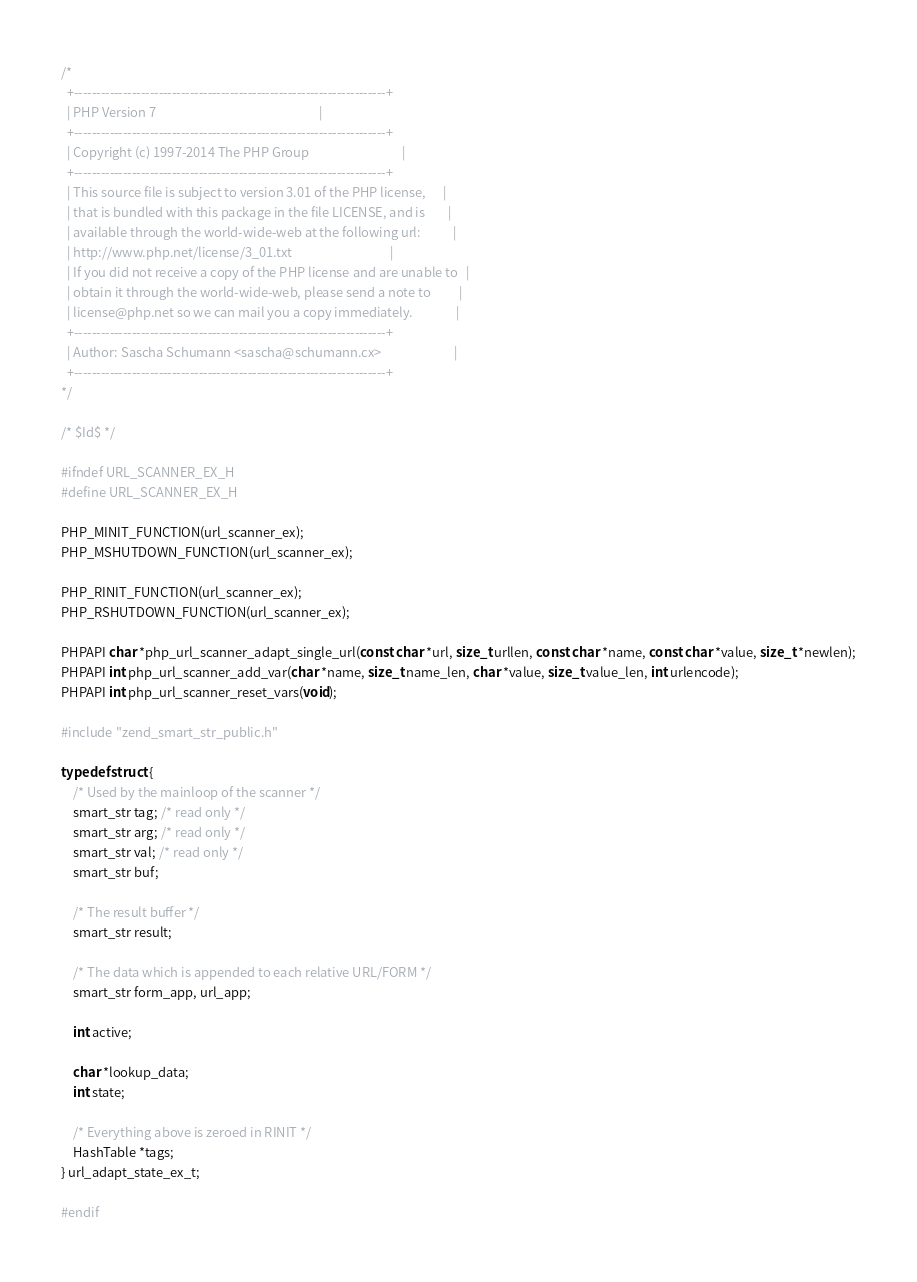<code> <loc_0><loc_0><loc_500><loc_500><_C_>/*
  +----------------------------------------------------------------------+
  | PHP Version 7                                                        |
  +----------------------------------------------------------------------+
  | Copyright (c) 1997-2014 The PHP Group                                |
  +----------------------------------------------------------------------+
  | This source file is subject to version 3.01 of the PHP license,      |
  | that is bundled with this package in the file LICENSE, and is        |
  | available through the world-wide-web at the following url:           |
  | http://www.php.net/license/3_01.txt                                  |
  | If you did not receive a copy of the PHP license and are unable to   |
  | obtain it through the world-wide-web, please send a note to          |
  | license@php.net so we can mail you a copy immediately.               |
  +----------------------------------------------------------------------+
  | Author: Sascha Schumann <sascha@schumann.cx>                         |
  +----------------------------------------------------------------------+
*/

/* $Id$ */

#ifndef URL_SCANNER_EX_H
#define URL_SCANNER_EX_H

PHP_MINIT_FUNCTION(url_scanner_ex);
PHP_MSHUTDOWN_FUNCTION(url_scanner_ex);

PHP_RINIT_FUNCTION(url_scanner_ex);
PHP_RSHUTDOWN_FUNCTION(url_scanner_ex);

PHPAPI char *php_url_scanner_adapt_single_url(const char *url, size_t urllen, const char *name, const char *value, size_t *newlen);
PHPAPI int php_url_scanner_add_var(char *name, size_t name_len, char *value, size_t value_len, int urlencode);
PHPAPI int php_url_scanner_reset_vars(void);

#include "zend_smart_str_public.h"

typedef struct {
	/* Used by the mainloop of the scanner */
	smart_str tag; /* read only */
	smart_str arg; /* read only */
	smart_str val; /* read only */
	smart_str buf;

	/* The result buffer */
	smart_str result;

	/* The data which is appended to each relative URL/FORM */
	smart_str form_app, url_app;

	int active;

	char *lookup_data;
	int state;
	
	/* Everything above is zeroed in RINIT */
	HashTable *tags;
} url_adapt_state_ex_t;

#endif
</code> 